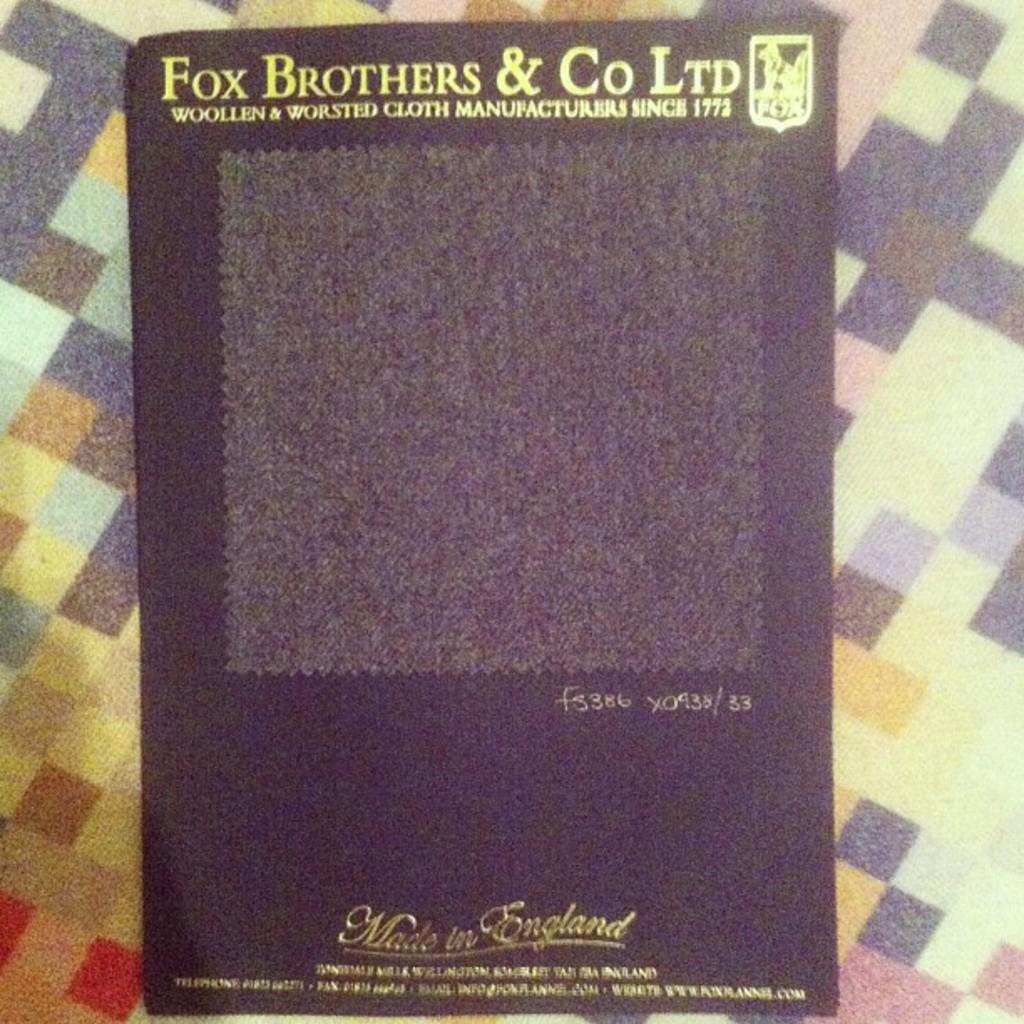What is the name of the company?
Make the answer very short. Fox brothers & co ltd. Who is the manufacturer?
Keep it short and to the point. Fox brothers & co ltd. 